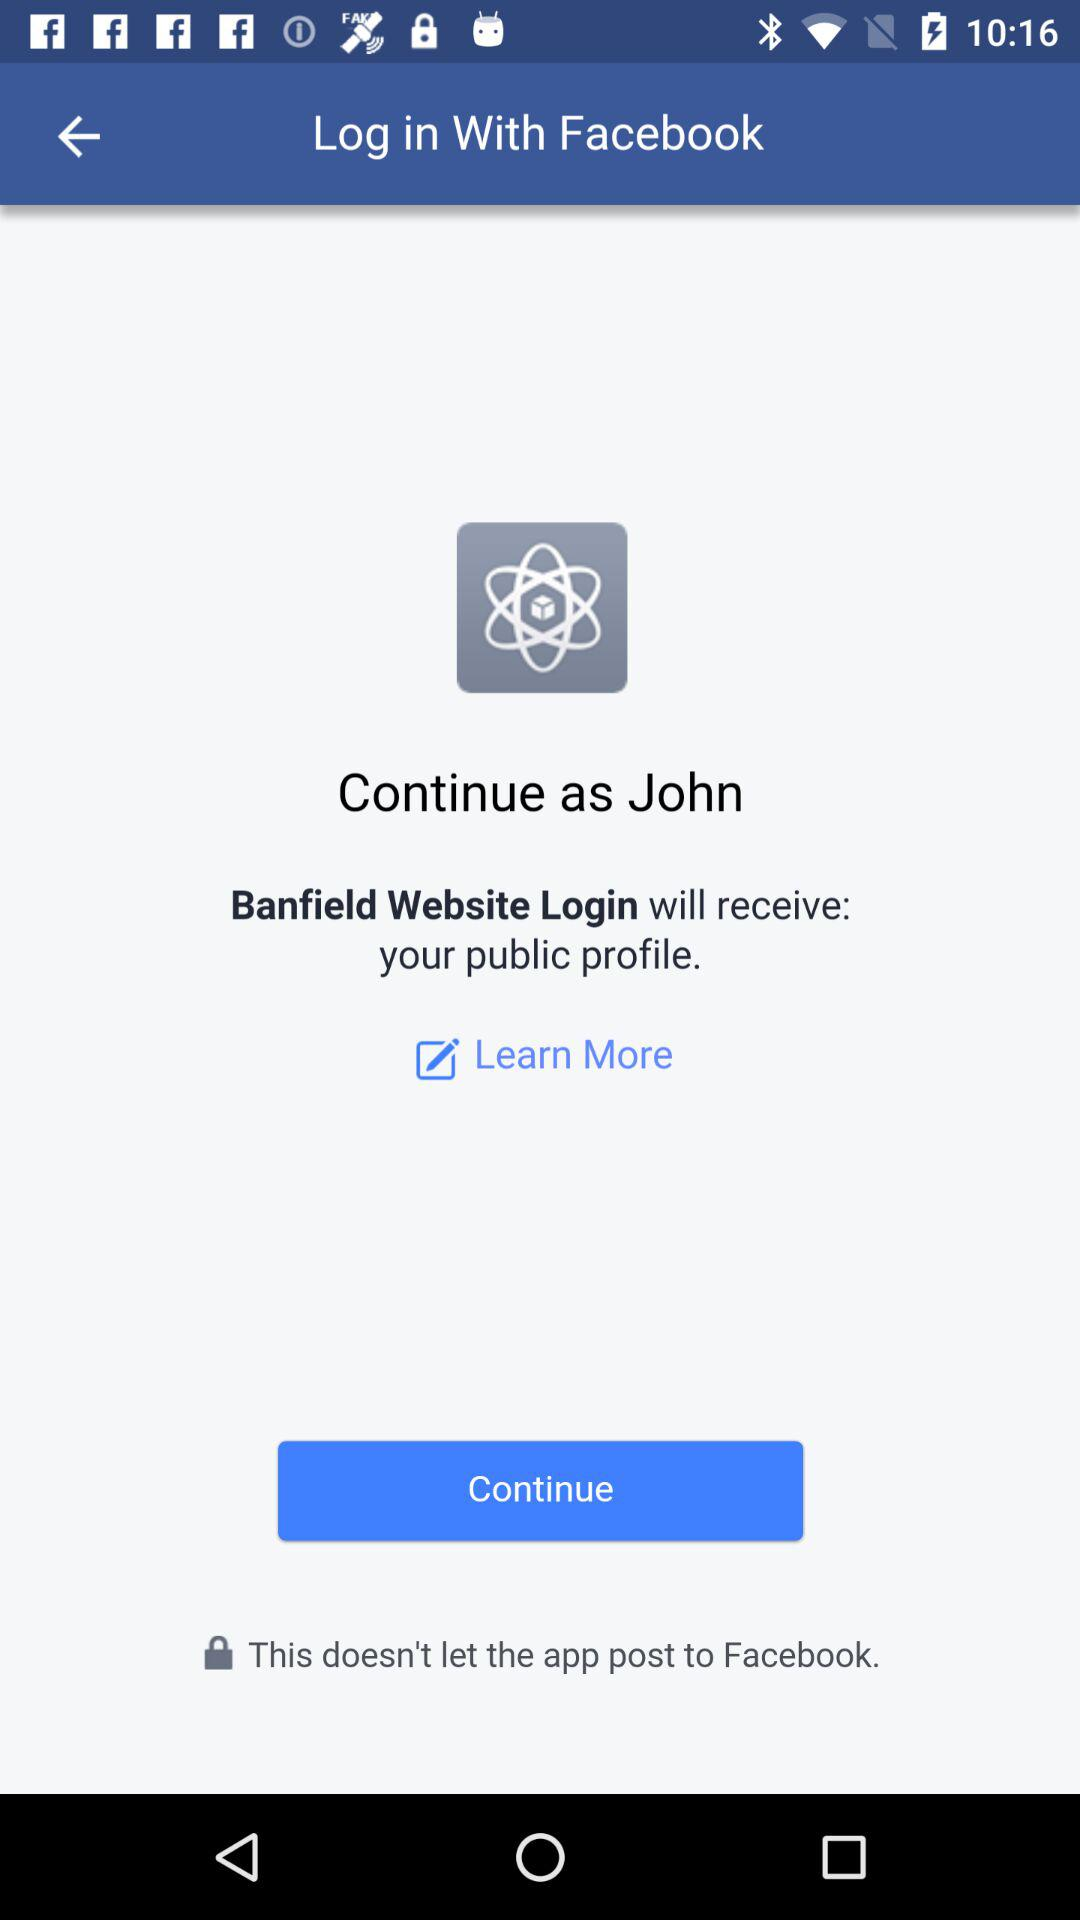What is the user's last name?
When the provided information is insufficient, respond with <no answer>. <no answer> 